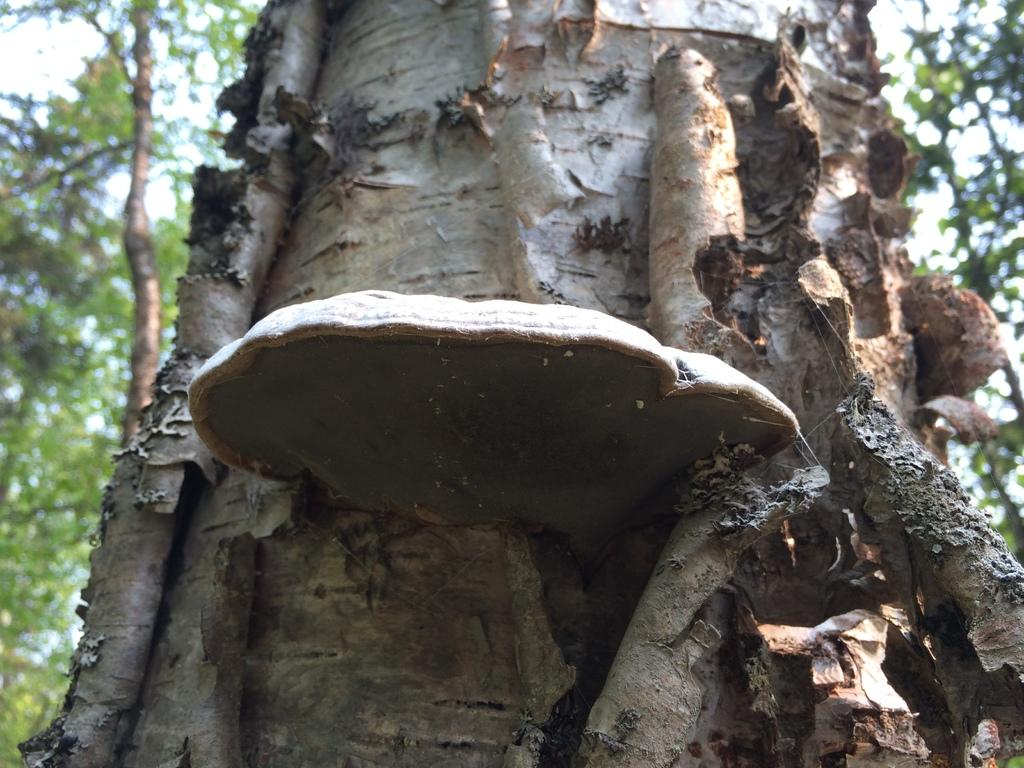What colors can be seen on the trunk of the tree in the image? The trunk of the tree is black, brown, and ash in color. What is growing on the tree in the image? There is fungus on the tree. What can be seen in the background of the image? Trees and the sky are visible in the background of the image. What type of caption is written on the tree in the image? There is no caption written on the tree in the image. Can you see a road in the image? There is no road visible in the image. 